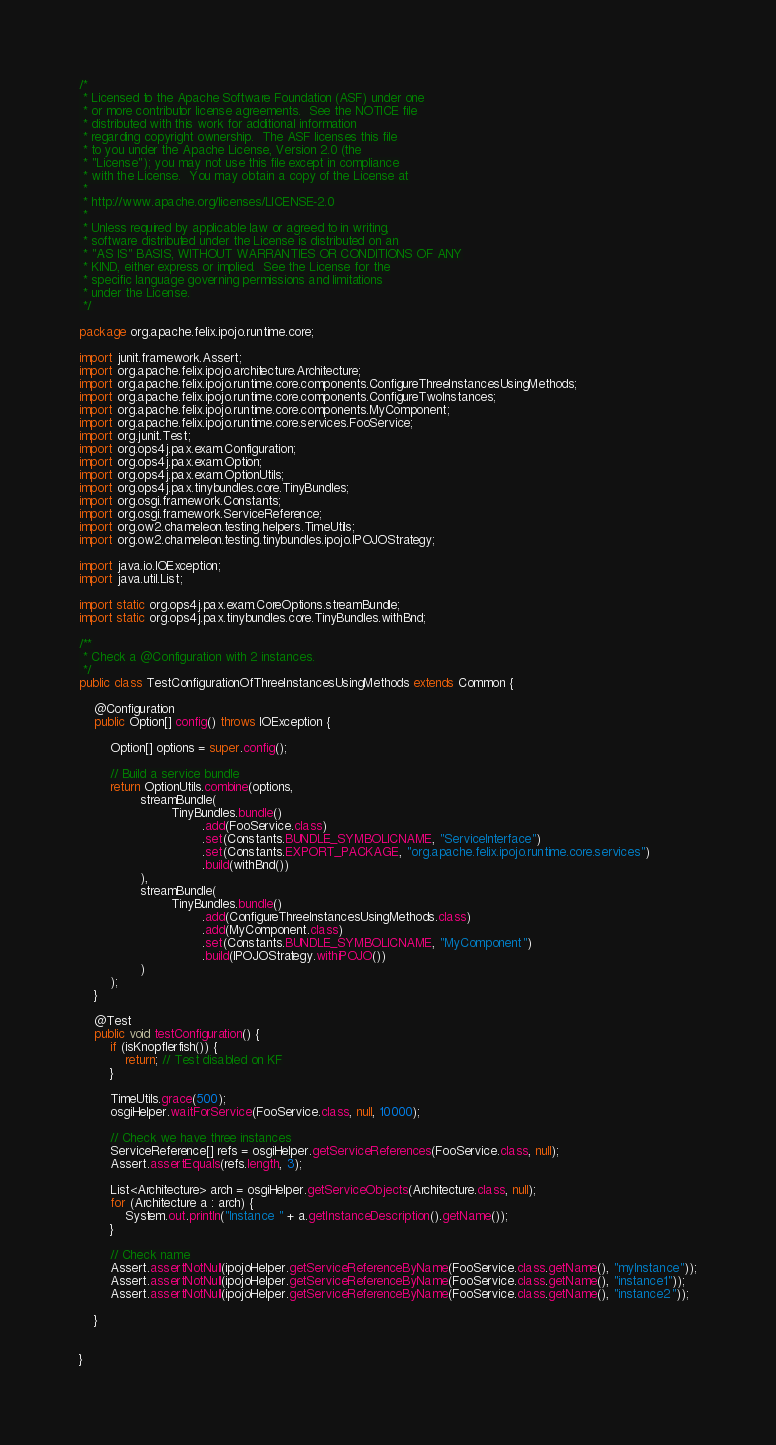<code> <loc_0><loc_0><loc_500><loc_500><_Java_>/*
 * Licensed to the Apache Software Foundation (ASF) under one
 * or more contributor license agreements.  See the NOTICE file
 * distributed with this work for additional information
 * regarding copyright ownership.  The ASF licenses this file
 * to you under the Apache License, Version 2.0 (the
 * "License"); you may not use this file except in compliance
 * with the License.  You may obtain a copy of the License at
 *
 * http://www.apache.org/licenses/LICENSE-2.0
 *
 * Unless required by applicable law or agreed to in writing,
 * software distributed under the License is distributed on an
 * "AS IS" BASIS, WITHOUT WARRANTIES OR CONDITIONS OF ANY
 * KIND, either express or implied.  See the License for the
 * specific language governing permissions and limitations
 * under the License.
 */

package org.apache.felix.ipojo.runtime.core;

import junit.framework.Assert;
import org.apache.felix.ipojo.architecture.Architecture;
import org.apache.felix.ipojo.runtime.core.components.ConfigureThreeInstancesUsingMethods;
import org.apache.felix.ipojo.runtime.core.components.ConfigureTwoInstances;
import org.apache.felix.ipojo.runtime.core.components.MyComponent;
import org.apache.felix.ipojo.runtime.core.services.FooService;
import org.junit.Test;
import org.ops4j.pax.exam.Configuration;
import org.ops4j.pax.exam.Option;
import org.ops4j.pax.exam.OptionUtils;
import org.ops4j.pax.tinybundles.core.TinyBundles;
import org.osgi.framework.Constants;
import org.osgi.framework.ServiceReference;
import org.ow2.chameleon.testing.helpers.TimeUtils;
import org.ow2.chameleon.testing.tinybundles.ipojo.IPOJOStrategy;

import java.io.IOException;
import java.util.List;

import static org.ops4j.pax.exam.CoreOptions.streamBundle;
import static org.ops4j.pax.tinybundles.core.TinyBundles.withBnd;

/**
 * Check a @Configuration with 2 instances.
 */
public class TestConfigurationOfThreeInstancesUsingMethods extends Common {

    @Configuration
    public Option[] config() throws IOException {

        Option[] options = super.config();

        // Build a service bundle
        return OptionUtils.combine(options,
                streamBundle(
                        TinyBundles.bundle()
                                .add(FooService.class)
                                .set(Constants.BUNDLE_SYMBOLICNAME, "ServiceInterface")
                                .set(Constants.EXPORT_PACKAGE, "org.apache.felix.ipojo.runtime.core.services")
                                .build(withBnd())
                ),
                streamBundle(
                        TinyBundles.bundle()
                                .add(ConfigureThreeInstancesUsingMethods.class)
                                .add(MyComponent.class)
                                .set(Constants.BUNDLE_SYMBOLICNAME, "MyComponent")
                                .build(IPOJOStrategy.withiPOJO())
                )
        );
    }

    @Test
    public void testConfiguration() {
        if (isKnopflerfish()) {
            return; // Test disabled on KF
        }

        TimeUtils.grace(500);
        osgiHelper.waitForService(FooService.class, null, 10000);

        // Check we have three instances
        ServiceReference[] refs = osgiHelper.getServiceReferences(FooService.class, null);
        Assert.assertEquals(refs.length, 3);

        List<Architecture> arch = osgiHelper.getServiceObjects(Architecture.class, null);
        for (Architecture a : arch) {
            System.out.println("Instance " + a.getInstanceDescription().getName());
        }

        // Check name
        Assert.assertNotNull(ipojoHelper.getServiceReferenceByName(FooService.class.getName(), "myInstance"));
        Assert.assertNotNull(ipojoHelper.getServiceReferenceByName(FooService.class.getName(), "instance1"));
        Assert.assertNotNull(ipojoHelper.getServiceReferenceByName(FooService.class.getName(), "instance2"));

    }


}
</code> 